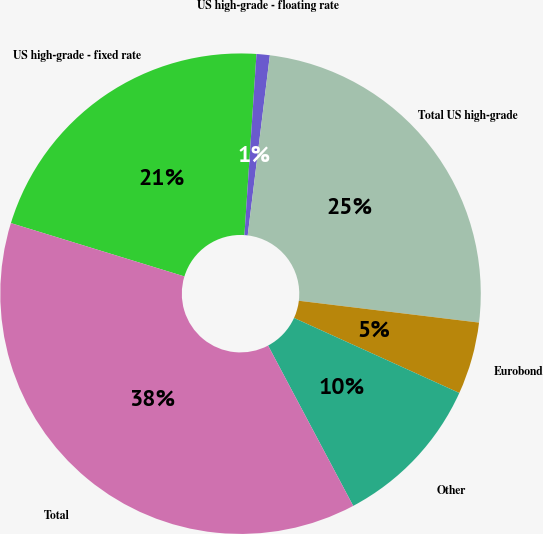Convert chart. <chart><loc_0><loc_0><loc_500><loc_500><pie_chart><fcel>US high-grade - fixed rate<fcel>US high-grade - floating rate<fcel>Total US high-grade<fcel>Eurobond<fcel>Other<fcel>Total<nl><fcel>21.31%<fcel>0.89%<fcel>24.97%<fcel>4.86%<fcel>10.45%<fcel>37.51%<nl></chart> 